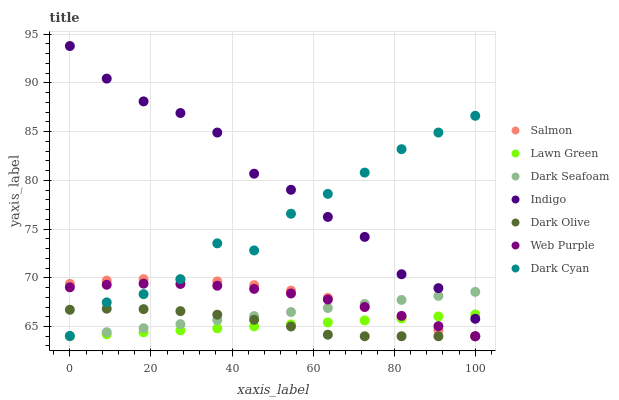Does Lawn Green have the minimum area under the curve?
Answer yes or no. Yes. Does Indigo have the maximum area under the curve?
Answer yes or no. Yes. Does Dark Olive have the minimum area under the curve?
Answer yes or no. No. Does Dark Olive have the maximum area under the curve?
Answer yes or no. No. Is Lawn Green the smoothest?
Answer yes or no. Yes. Is Dark Cyan the roughest?
Answer yes or no. Yes. Is Indigo the smoothest?
Answer yes or no. No. Is Indigo the roughest?
Answer yes or no. No. Does Lawn Green have the lowest value?
Answer yes or no. Yes. Does Indigo have the lowest value?
Answer yes or no. No. Does Indigo have the highest value?
Answer yes or no. Yes. Does Dark Olive have the highest value?
Answer yes or no. No. Is Web Purple less than Indigo?
Answer yes or no. Yes. Is Indigo greater than Web Purple?
Answer yes or no. Yes. Does Dark Cyan intersect Indigo?
Answer yes or no. Yes. Is Dark Cyan less than Indigo?
Answer yes or no. No. Is Dark Cyan greater than Indigo?
Answer yes or no. No. Does Web Purple intersect Indigo?
Answer yes or no. No. 